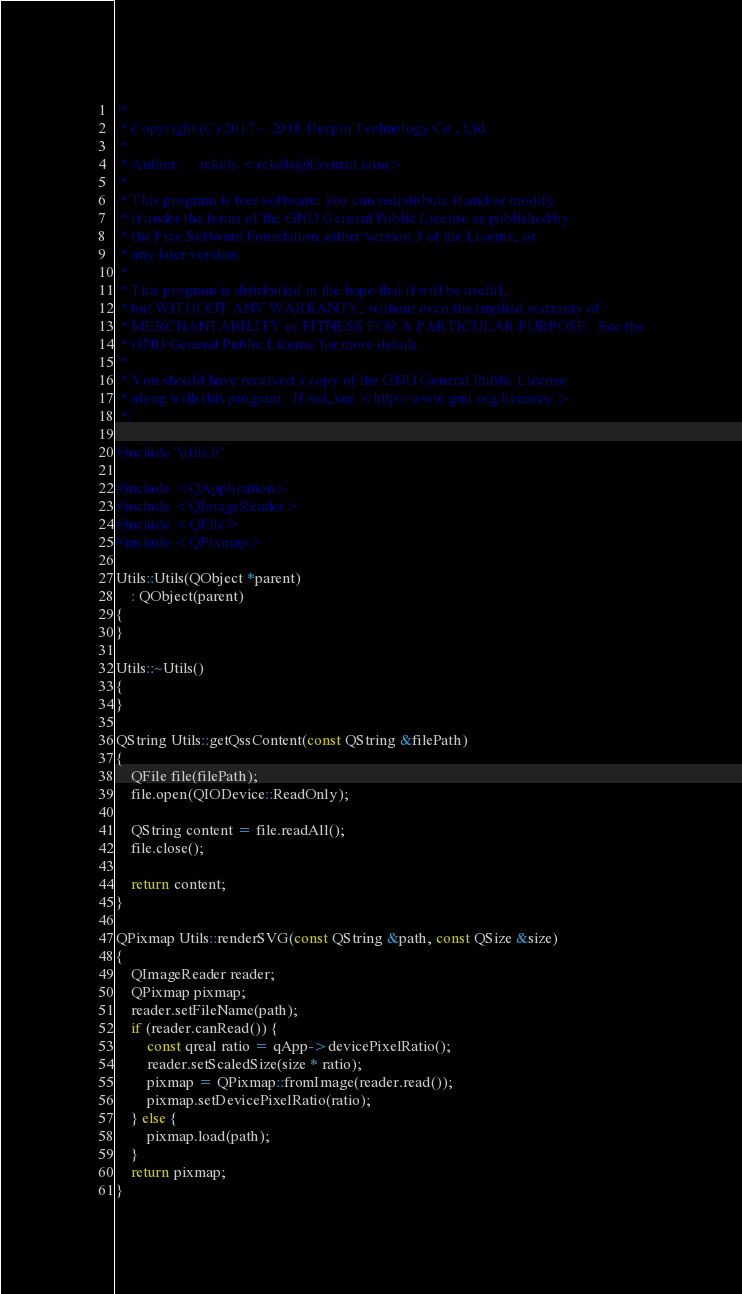Convert code to text. <code><loc_0><loc_0><loc_500><loc_500><_C++_>/*
 * Copyright (C) 2017 ~ 2018 Deepin Technology Co., Ltd.
 *
 * Author:     rekols <rekols@foxmail.com>
 *
 * This program is free software: you can redistribute it and/or modify
 * it under the terms of the GNU General Public License as published by
 * the Free Software Foundation, either version 3 of the License, or
 * any later version.
 *
 * This program is distributed in the hope that it will be useful,
 * but WITHOUT ANY WARRANTY; without even the implied warranty of
 * MERCHANTABILITY or FITNESS FOR A PARTICULAR PURPOSE.  See the
 * GNU General Public License for more details.
 *
 * You should have received a copy of the GNU General Public License
 * along with this program.  If not, see <http://www.gnu.org/licenses/>.
 */

#include "utils.h"

#include <QApplication>
#include <QImageReader>
#include <QFile>
#include <QPixmap>

Utils::Utils(QObject *parent)
    : QObject(parent)
{
}

Utils::~Utils()
{
}

QString Utils::getQssContent(const QString &filePath)
{
    QFile file(filePath);
    file.open(QIODevice::ReadOnly);

    QString content = file.readAll();
    file.close();

    return content;
}

QPixmap Utils::renderSVG(const QString &path, const QSize &size)
{
    QImageReader reader;
    QPixmap pixmap;
    reader.setFileName(path);
    if (reader.canRead()) {
        const qreal ratio = qApp->devicePixelRatio();
        reader.setScaledSize(size * ratio);
        pixmap = QPixmap::fromImage(reader.read());
        pixmap.setDevicePixelRatio(ratio);
    } else {
        pixmap.load(path);
    }
    return pixmap;
}
</code> 